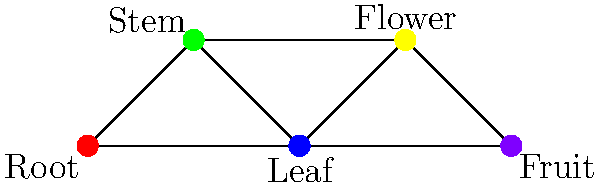In the graph above, different plant tissues are represented as vertices, and edges connect tissues that share similar gene expression patterns. The colors represent distinct gene expression profiles. What is the chromatic number of this graph, and what does it signify in terms of gene expression patterns across plant tissues? To determine the chromatic number and its significance, let's follow these steps:

1. Understand the graph:
   - Each vertex represents a plant tissue (Root, Stem, Leaf, Flower, Fruit).
   - Edges connect tissues with similar gene expression patterns.
   - Colors represent distinct gene expression profiles.

2. Analyze the coloring:
   - We see 5 different colors used: red, green, blue, yellow, and purple.
   - Each vertex has a unique color.

3. Determine the chromatic number:
   - The chromatic number is the minimum number of colors needed to color the graph such that no adjacent vertices have the same color.
   - In this case, the chromatic number is 5, as all 5 vertices have different colors and are connected to each other.

4. Interpret the significance:
   - Each color represents a distinct gene expression profile.
   - The chromatic number of 5 indicates that all five tissues have unique gene expression patterns.
   - No two connected tissues share the same gene expression profile.

5. Biological interpretation:
   - This suggests that each plant tissue (Root, Stem, Leaf, Flower, and Fruit) has a unique set of expressed genes.
   - The high chromatic number implies a high degree of tissue-specific gene expression in the plant.
   - This differentiation in gene expression is crucial for the specialized functions of each tissue type.
Answer: Chromatic number: 5; Signifies unique gene expression profiles in all five plant tissues. 